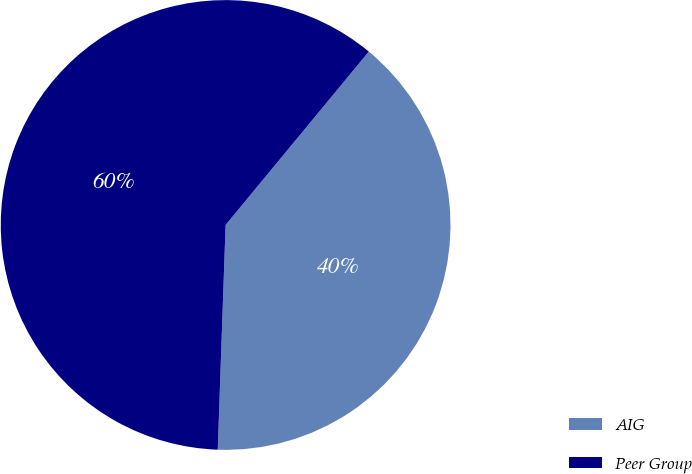Convert chart. <chart><loc_0><loc_0><loc_500><loc_500><pie_chart><fcel>AIG<fcel>Peer Group<nl><fcel>39.57%<fcel>60.43%<nl></chart> 